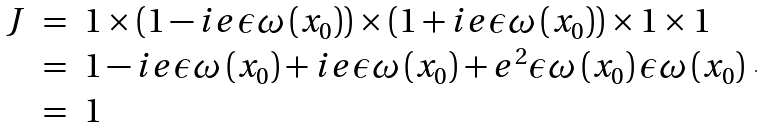<formula> <loc_0><loc_0><loc_500><loc_500>\begin{array} { r c l } J & = & 1 \times \left ( 1 - i e \epsilon \omega \left ( x _ { 0 } \right ) \right ) \times \left ( 1 + i e \epsilon \omega \left ( x _ { 0 } \right ) \right ) \times 1 \times 1 \\ & = & 1 - i e \epsilon \omega \left ( x _ { 0 } \right ) + i e \epsilon \omega \left ( x _ { 0 } \right ) + e ^ { 2 } \epsilon \omega \left ( x _ { 0 } \right ) \epsilon \omega \left ( x _ { 0 } \right ) \\ & = & 1 \end{array} .</formula> 